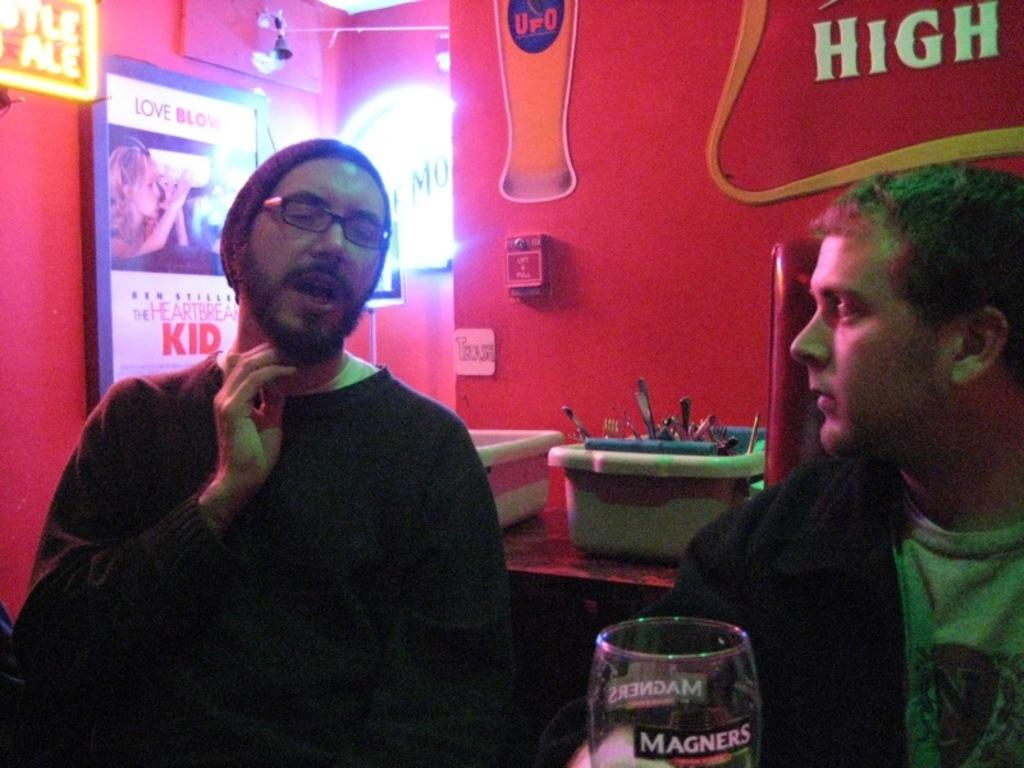How many people are in the image? There are two people in the image. What is one of the people doing in the image? One person is talking. Can you describe the appearance of the person talking? The person talking is wearing glasses. What can be seen in the background of the image? There is a wall in the background of the image, and there are stickers on the wall. What other objects are visible in the background? There are baskets in the background. What type of sand can be seen on the library floor in the image? There is no sand or library present in the image; it features two people and a background with a wall, stickers, and baskets. 